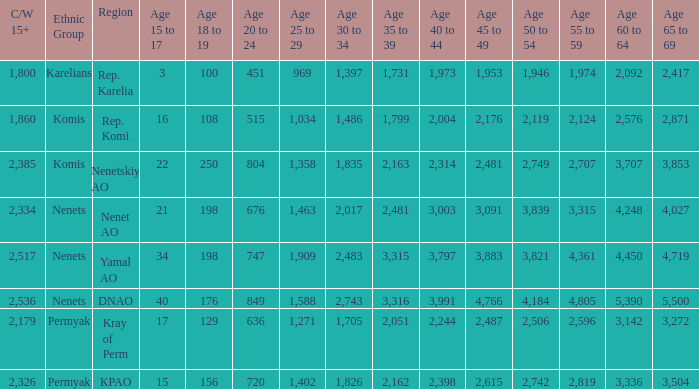With a 20 to 24 less than 676, and a 15 to 17 greater than 16, and a 60 to 64 less than 3,142, what is the average 45 to 49? None. 